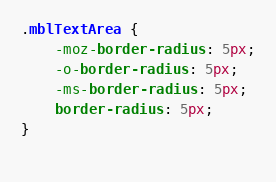Convert code to text. <code><loc_0><loc_0><loc_500><loc_500><_CSS_>
.mblTextArea {
	-moz-border-radius: 5px;
	-o-border-radius: 5px;
	-ms-border-radius: 5px;
	border-radius: 5px;
}
 </code> 